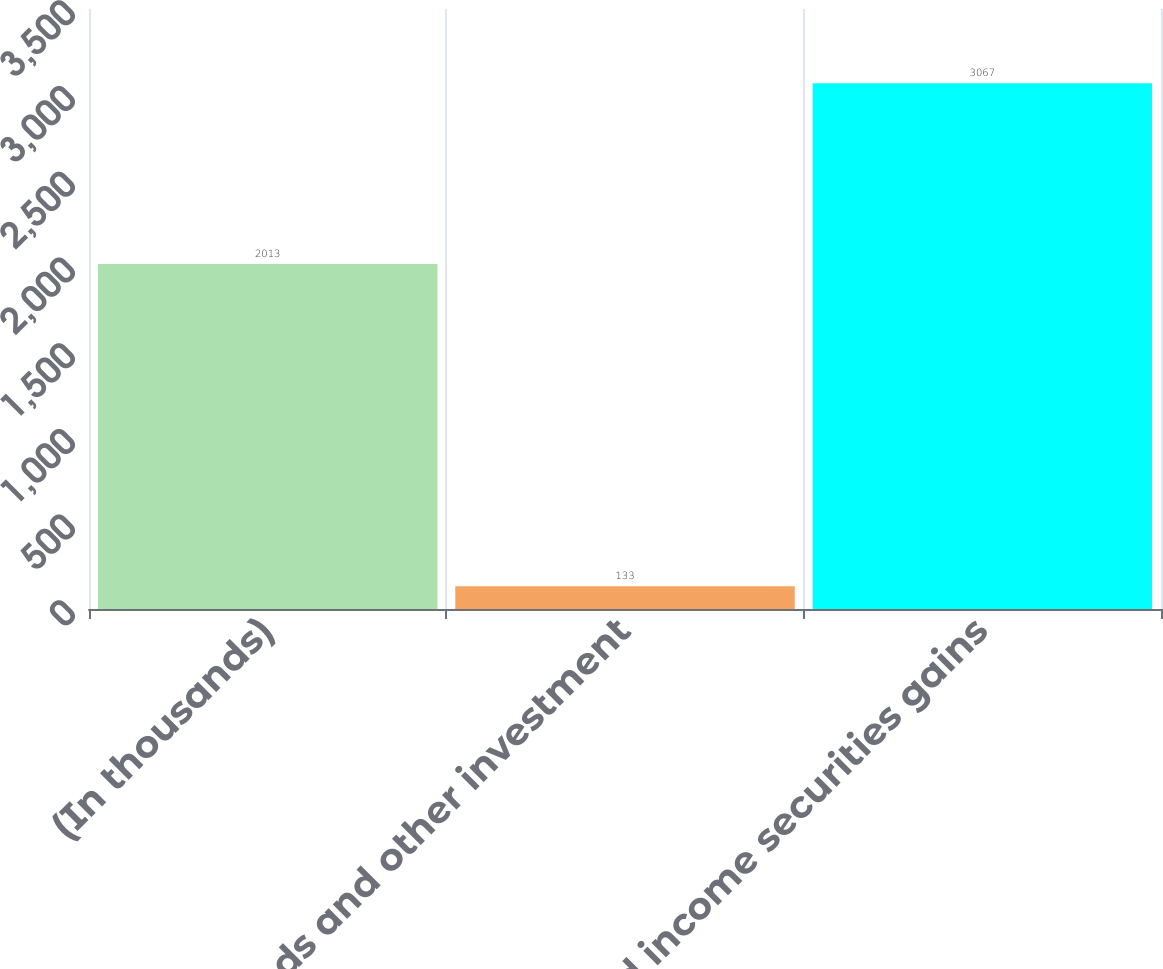Convert chart to OTSL. <chart><loc_0><loc_0><loc_500><loc_500><bar_chart><fcel>(In thousands)<fcel>Dividends and other investment<fcel>Fixed income securities gains<nl><fcel>2013<fcel>133<fcel>3067<nl></chart> 